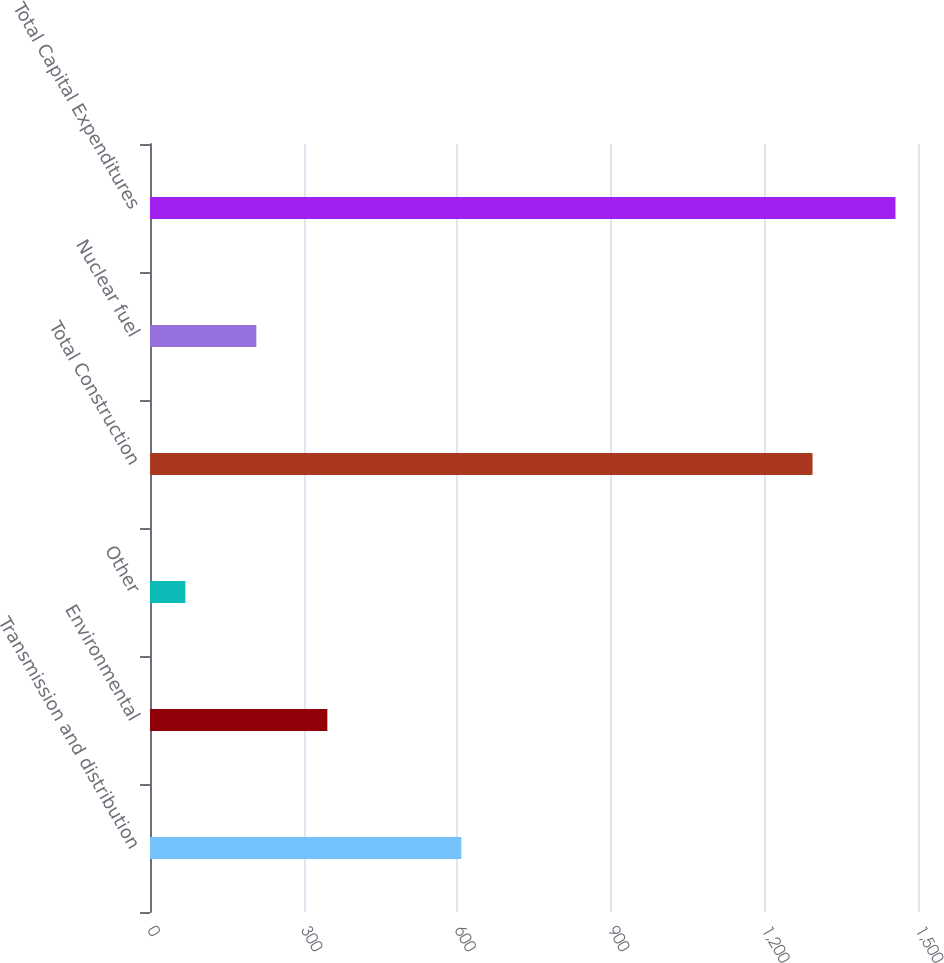Convert chart. <chart><loc_0><loc_0><loc_500><loc_500><bar_chart><fcel>Transmission and distribution<fcel>Environmental<fcel>Other<fcel>Total Construction<fcel>Nuclear fuel<fcel>Total Capital Expenditures<nl><fcel>608<fcel>346.4<fcel>69<fcel>1294<fcel>207.7<fcel>1456<nl></chart> 